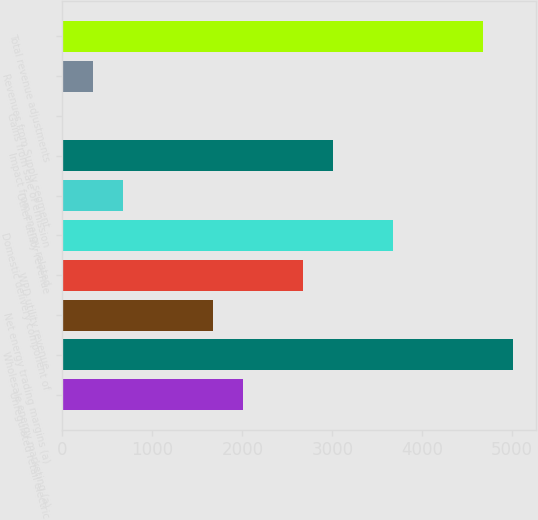<chart> <loc_0><loc_0><loc_500><loc_500><bar_chart><fcel>Unregulated retail electric<fcel>Wholesale energy marketing (a)<fcel>Net energy trading margins (a)<fcel>WPD utility revenue<fcel>Domestic delivery component of<fcel>Other utility revenue<fcel>Impact from energy-related<fcel>Gains from sale of emission<fcel>Revenues from Supply segment<fcel>Total revenue adjustments<nl><fcel>2008.8<fcel>5013<fcel>1675<fcel>2676.4<fcel>3677.8<fcel>673.6<fcel>3010.2<fcel>6<fcel>339.8<fcel>4679.2<nl></chart> 